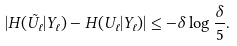<formula> <loc_0><loc_0><loc_500><loc_500>| H ( \tilde { U } _ { \ell } | Y _ { \ell } ) - H ( U _ { \ell } | Y _ { \ell } ) | \leq - \delta \log \frac { \delta } { 5 } .</formula> 